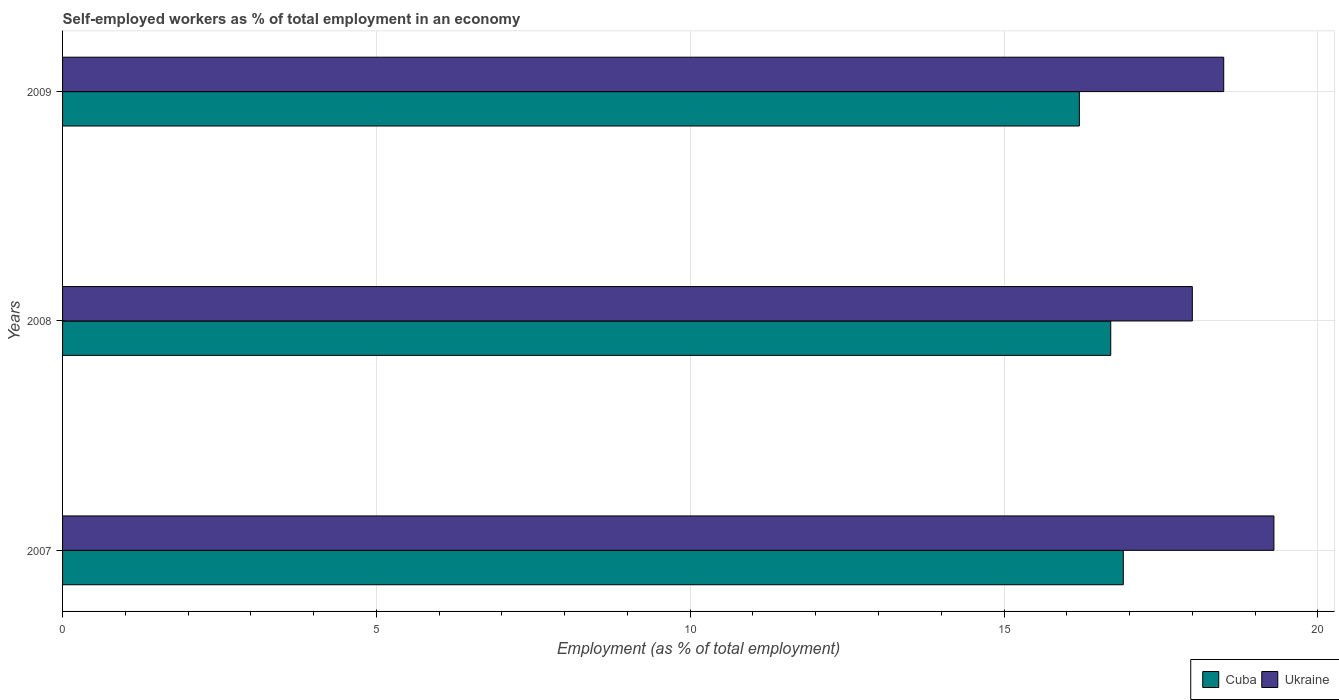How many different coloured bars are there?
Offer a terse response. 2. Are the number of bars on each tick of the Y-axis equal?
Your answer should be compact. Yes. How many bars are there on the 3rd tick from the bottom?
Keep it short and to the point. 2. In how many cases, is the number of bars for a given year not equal to the number of legend labels?
Provide a succinct answer. 0. What is the percentage of self-employed workers in Cuba in 2009?
Offer a very short reply. 16.2. Across all years, what is the maximum percentage of self-employed workers in Ukraine?
Your answer should be compact. 19.3. Across all years, what is the minimum percentage of self-employed workers in Cuba?
Provide a succinct answer. 16.2. In which year was the percentage of self-employed workers in Cuba maximum?
Your response must be concise. 2007. In which year was the percentage of self-employed workers in Cuba minimum?
Provide a short and direct response. 2009. What is the total percentage of self-employed workers in Cuba in the graph?
Your answer should be compact. 49.8. What is the difference between the percentage of self-employed workers in Ukraine in 2007 and that in 2009?
Offer a terse response. 0.8. What is the difference between the percentage of self-employed workers in Ukraine in 2008 and the percentage of self-employed workers in Cuba in 2007?
Give a very brief answer. 1.1. What is the average percentage of self-employed workers in Cuba per year?
Ensure brevity in your answer.  16.6. In the year 2009, what is the difference between the percentage of self-employed workers in Cuba and percentage of self-employed workers in Ukraine?
Keep it short and to the point. -2.3. What is the ratio of the percentage of self-employed workers in Ukraine in 2007 to that in 2009?
Ensure brevity in your answer.  1.04. Is the percentage of self-employed workers in Ukraine in 2007 less than that in 2009?
Offer a terse response. No. Is the difference between the percentage of self-employed workers in Cuba in 2007 and 2009 greater than the difference between the percentage of self-employed workers in Ukraine in 2007 and 2009?
Offer a very short reply. No. What is the difference between the highest and the second highest percentage of self-employed workers in Cuba?
Provide a succinct answer. 0.2. What is the difference between the highest and the lowest percentage of self-employed workers in Ukraine?
Your answer should be very brief. 1.3. What does the 1st bar from the top in 2008 represents?
Your response must be concise. Ukraine. What does the 1st bar from the bottom in 2007 represents?
Offer a terse response. Cuba. Are all the bars in the graph horizontal?
Ensure brevity in your answer.  Yes. How many years are there in the graph?
Provide a succinct answer. 3. What is the difference between two consecutive major ticks on the X-axis?
Make the answer very short. 5. Does the graph contain any zero values?
Provide a short and direct response. No. Where does the legend appear in the graph?
Give a very brief answer. Bottom right. How many legend labels are there?
Offer a terse response. 2. How are the legend labels stacked?
Your answer should be very brief. Horizontal. What is the title of the graph?
Provide a short and direct response. Self-employed workers as % of total employment in an economy. What is the label or title of the X-axis?
Your answer should be very brief. Employment (as % of total employment). What is the label or title of the Y-axis?
Give a very brief answer. Years. What is the Employment (as % of total employment) in Cuba in 2007?
Ensure brevity in your answer.  16.9. What is the Employment (as % of total employment) of Ukraine in 2007?
Ensure brevity in your answer.  19.3. What is the Employment (as % of total employment) of Cuba in 2008?
Make the answer very short. 16.7. What is the Employment (as % of total employment) in Ukraine in 2008?
Your response must be concise. 18. What is the Employment (as % of total employment) in Cuba in 2009?
Give a very brief answer. 16.2. What is the Employment (as % of total employment) in Ukraine in 2009?
Offer a very short reply. 18.5. Across all years, what is the maximum Employment (as % of total employment) of Cuba?
Ensure brevity in your answer.  16.9. Across all years, what is the maximum Employment (as % of total employment) in Ukraine?
Provide a short and direct response. 19.3. Across all years, what is the minimum Employment (as % of total employment) in Cuba?
Ensure brevity in your answer.  16.2. What is the total Employment (as % of total employment) in Cuba in the graph?
Provide a succinct answer. 49.8. What is the total Employment (as % of total employment) in Ukraine in the graph?
Provide a succinct answer. 55.8. What is the difference between the Employment (as % of total employment) in Ukraine in 2007 and that in 2008?
Offer a very short reply. 1.3. What is the difference between the Employment (as % of total employment) of Ukraine in 2007 and that in 2009?
Your answer should be very brief. 0.8. What is the difference between the Employment (as % of total employment) in Cuba in 2008 and that in 2009?
Your answer should be compact. 0.5. What is the difference between the Employment (as % of total employment) in Cuba in 2007 and the Employment (as % of total employment) in Ukraine in 2008?
Keep it short and to the point. -1.1. What is the difference between the Employment (as % of total employment) in Cuba in 2007 and the Employment (as % of total employment) in Ukraine in 2009?
Your response must be concise. -1.6. What is the average Employment (as % of total employment) of Cuba per year?
Keep it short and to the point. 16.6. What is the average Employment (as % of total employment) in Ukraine per year?
Ensure brevity in your answer.  18.6. In the year 2007, what is the difference between the Employment (as % of total employment) in Cuba and Employment (as % of total employment) in Ukraine?
Give a very brief answer. -2.4. In the year 2008, what is the difference between the Employment (as % of total employment) of Cuba and Employment (as % of total employment) of Ukraine?
Make the answer very short. -1.3. In the year 2009, what is the difference between the Employment (as % of total employment) in Cuba and Employment (as % of total employment) in Ukraine?
Make the answer very short. -2.3. What is the ratio of the Employment (as % of total employment) in Cuba in 2007 to that in 2008?
Give a very brief answer. 1.01. What is the ratio of the Employment (as % of total employment) of Ukraine in 2007 to that in 2008?
Make the answer very short. 1.07. What is the ratio of the Employment (as % of total employment) in Cuba in 2007 to that in 2009?
Your response must be concise. 1.04. What is the ratio of the Employment (as % of total employment) in Ukraine in 2007 to that in 2009?
Your answer should be very brief. 1.04. What is the ratio of the Employment (as % of total employment) of Cuba in 2008 to that in 2009?
Your response must be concise. 1.03. What is the ratio of the Employment (as % of total employment) of Ukraine in 2008 to that in 2009?
Provide a succinct answer. 0.97. What is the difference between the highest and the second highest Employment (as % of total employment) in Cuba?
Your answer should be compact. 0.2. What is the difference between the highest and the second highest Employment (as % of total employment) in Ukraine?
Give a very brief answer. 0.8. What is the difference between the highest and the lowest Employment (as % of total employment) of Ukraine?
Ensure brevity in your answer.  1.3. 